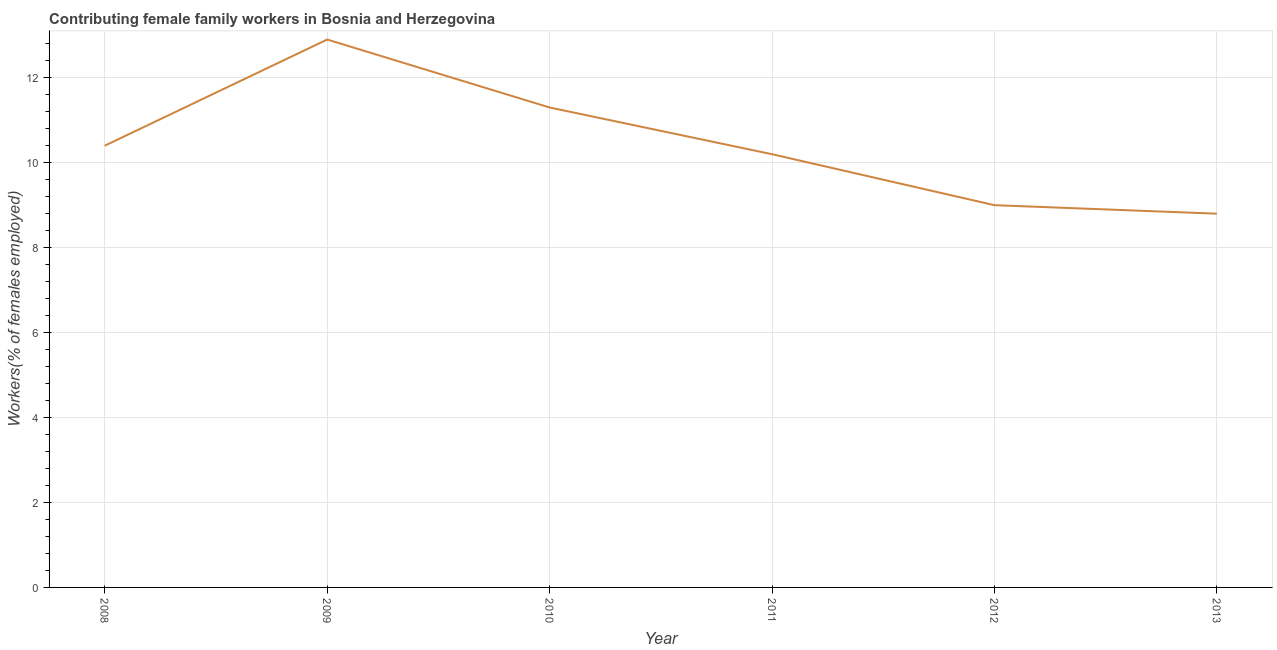What is the contributing female family workers in 2010?
Your answer should be compact. 11.3. Across all years, what is the maximum contributing female family workers?
Your answer should be compact. 12.9. Across all years, what is the minimum contributing female family workers?
Ensure brevity in your answer.  8.8. In which year was the contributing female family workers maximum?
Make the answer very short. 2009. What is the sum of the contributing female family workers?
Offer a very short reply. 62.6. What is the difference between the contributing female family workers in 2008 and 2009?
Your answer should be compact. -2.5. What is the average contributing female family workers per year?
Give a very brief answer. 10.43. What is the median contributing female family workers?
Offer a very short reply. 10.3. Do a majority of the years between 2009 and 2008 (inclusive) have contributing female family workers greater than 11.6 %?
Your answer should be very brief. No. What is the ratio of the contributing female family workers in 2008 to that in 2010?
Make the answer very short. 0.92. Is the contributing female family workers in 2008 less than that in 2011?
Your answer should be very brief. No. Is the difference between the contributing female family workers in 2010 and 2011 greater than the difference between any two years?
Ensure brevity in your answer.  No. What is the difference between the highest and the second highest contributing female family workers?
Your answer should be compact. 1.6. Is the sum of the contributing female family workers in 2009 and 2010 greater than the maximum contributing female family workers across all years?
Provide a succinct answer. Yes. What is the difference between the highest and the lowest contributing female family workers?
Your response must be concise. 4.1. Does the contributing female family workers monotonically increase over the years?
Give a very brief answer. No. How many years are there in the graph?
Provide a short and direct response. 6. What is the difference between two consecutive major ticks on the Y-axis?
Provide a succinct answer. 2. Does the graph contain any zero values?
Give a very brief answer. No. What is the title of the graph?
Ensure brevity in your answer.  Contributing female family workers in Bosnia and Herzegovina. What is the label or title of the X-axis?
Your response must be concise. Year. What is the label or title of the Y-axis?
Offer a very short reply. Workers(% of females employed). What is the Workers(% of females employed) of 2008?
Ensure brevity in your answer.  10.4. What is the Workers(% of females employed) of 2009?
Provide a succinct answer. 12.9. What is the Workers(% of females employed) of 2010?
Keep it short and to the point. 11.3. What is the Workers(% of females employed) of 2011?
Ensure brevity in your answer.  10.2. What is the Workers(% of females employed) in 2013?
Provide a short and direct response. 8.8. What is the difference between the Workers(% of females employed) in 2008 and 2010?
Your response must be concise. -0.9. What is the difference between the Workers(% of females employed) in 2008 and 2011?
Offer a very short reply. 0.2. What is the difference between the Workers(% of females employed) in 2008 and 2013?
Make the answer very short. 1.6. What is the difference between the Workers(% of females employed) in 2009 and 2010?
Your answer should be very brief. 1.6. What is the difference between the Workers(% of females employed) in 2009 and 2011?
Your answer should be compact. 2.7. What is the difference between the Workers(% of females employed) in 2010 and 2012?
Offer a terse response. 2.3. What is the difference between the Workers(% of females employed) in 2011 and 2012?
Offer a terse response. 1.2. What is the difference between the Workers(% of females employed) in 2011 and 2013?
Your answer should be compact. 1.4. What is the difference between the Workers(% of females employed) in 2012 and 2013?
Your answer should be very brief. 0.2. What is the ratio of the Workers(% of females employed) in 2008 to that in 2009?
Make the answer very short. 0.81. What is the ratio of the Workers(% of females employed) in 2008 to that in 2010?
Offer a very short reply. 0.92. What is the ratio of the Workers(% of females employed) in 2008 to that in 2011?
Ensure brevity in your answer.  1.02. What is the ratio of the Workers(% of females employed) in 2008 to that in 2012?
Give a very brief answer. 1.16. What is the ratio of the Workers(% of females employed) in 2008 to that in 2013?
Ensure brevity in your answer.  1.18. What is the ratio of the Workers(% of females employed) in 2009 to that in 2010?
Offer a terse response. 1.14. What is the ratio of the Workers(% of females employed) in 2009 to that in 2011?
Your answer should be very brief. 1.26. What is the ratio of the Workers(% of females employed) in 2009 to that in 2012?
Ensure brevity in your answer.  1.43. What is the ratio of the Workers(% of females employed) in 2009 to that in 2013?
Offer a terse response. 1.47. What is the ratio of the Workers(% of females employed) in 2010 to that in 2011?
Your answer should be compact. 1.11. What is the ratio of the Workers(% of females employed) in 2010 to that in 2012?
Offer a terse response. 1.26. What is the ratio of the Workers(% of females employed) in 2010 to that in 2013?
Offer a terse response. 1.28. What is the ratio of the Workers(% of females employed) in 2011 to that in 2012?
Provide a short and direct response. 1.13. What is the ratio of the Workers(% of females employed) in 2011 to that in 2013?
Your answer should be compact. 1.16. 